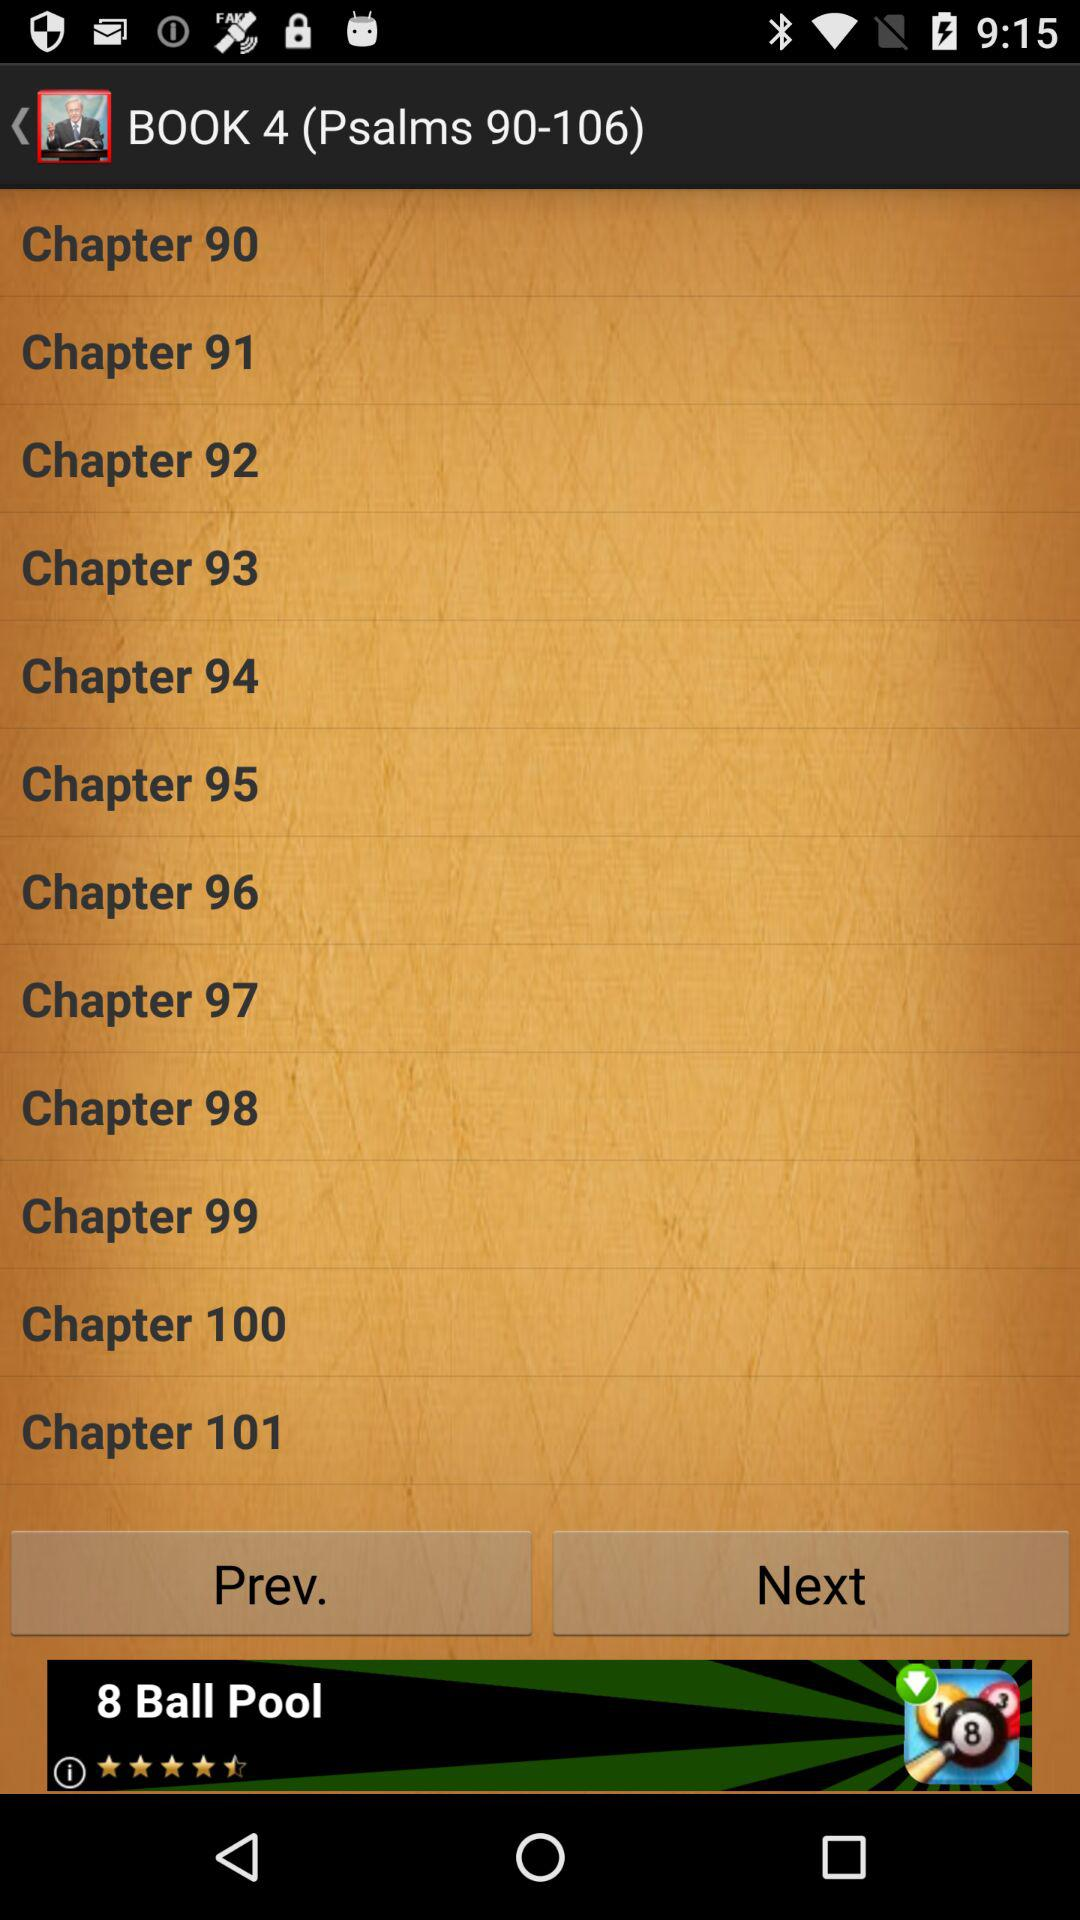How many verses are there in this chapter?
Answer the question using a single word or phrase. 9 